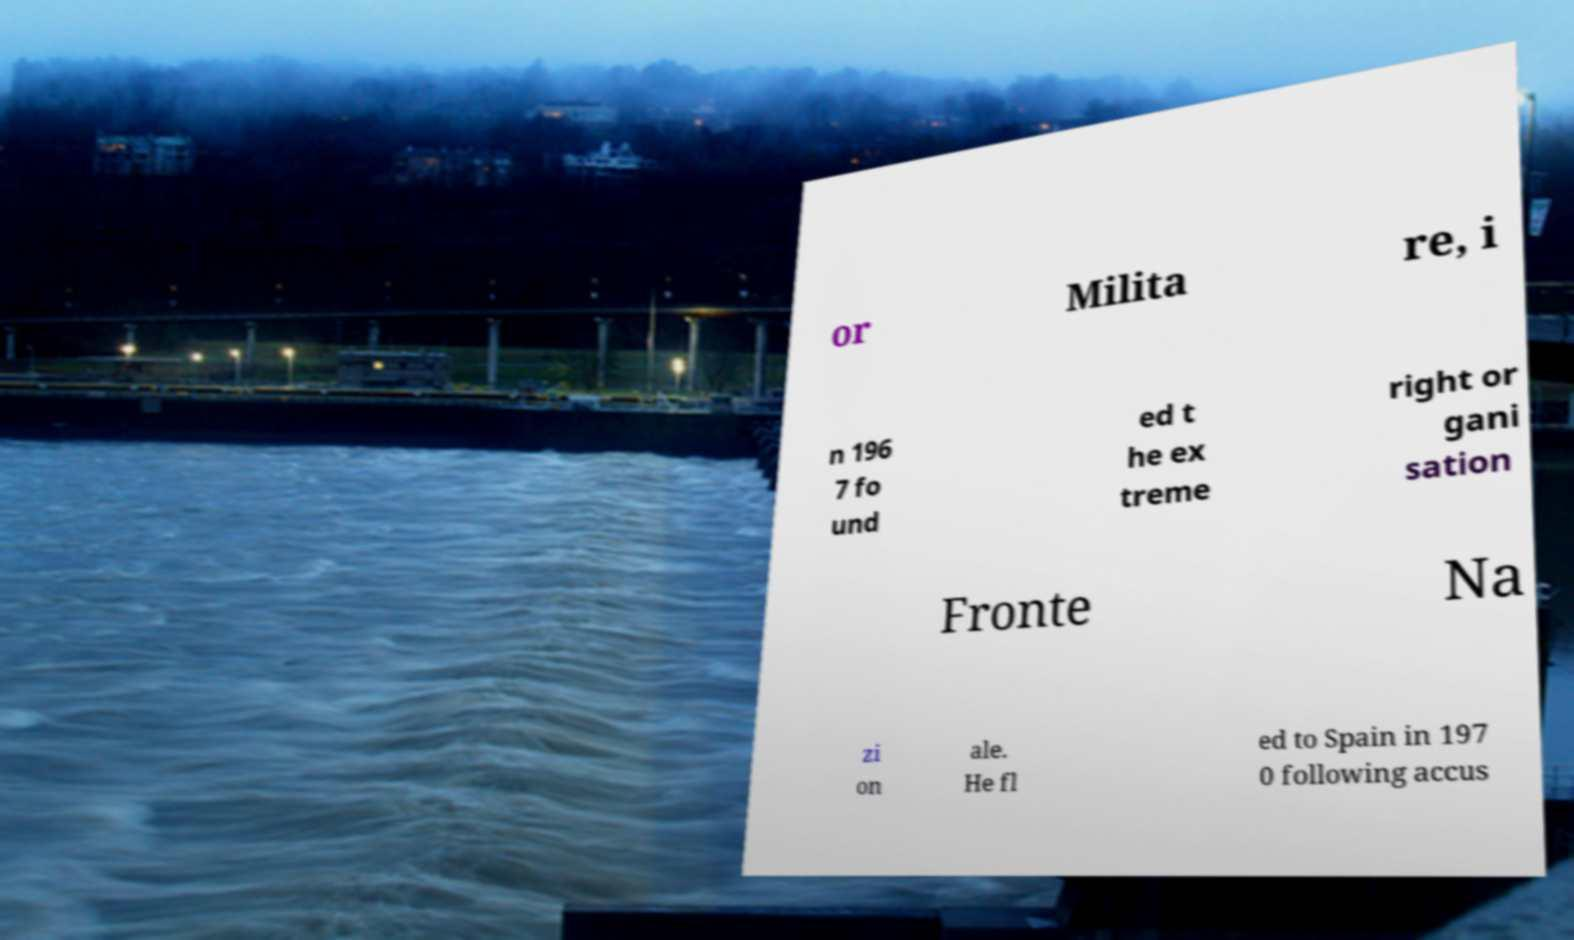Can you accurately transcribe the text from the provided image for me? or Milita re, i n 196 7 fo und ed t he ex treme right or gani sation Fronte Na zi on ale. He fl ed to Spain in 197 0 following accus 